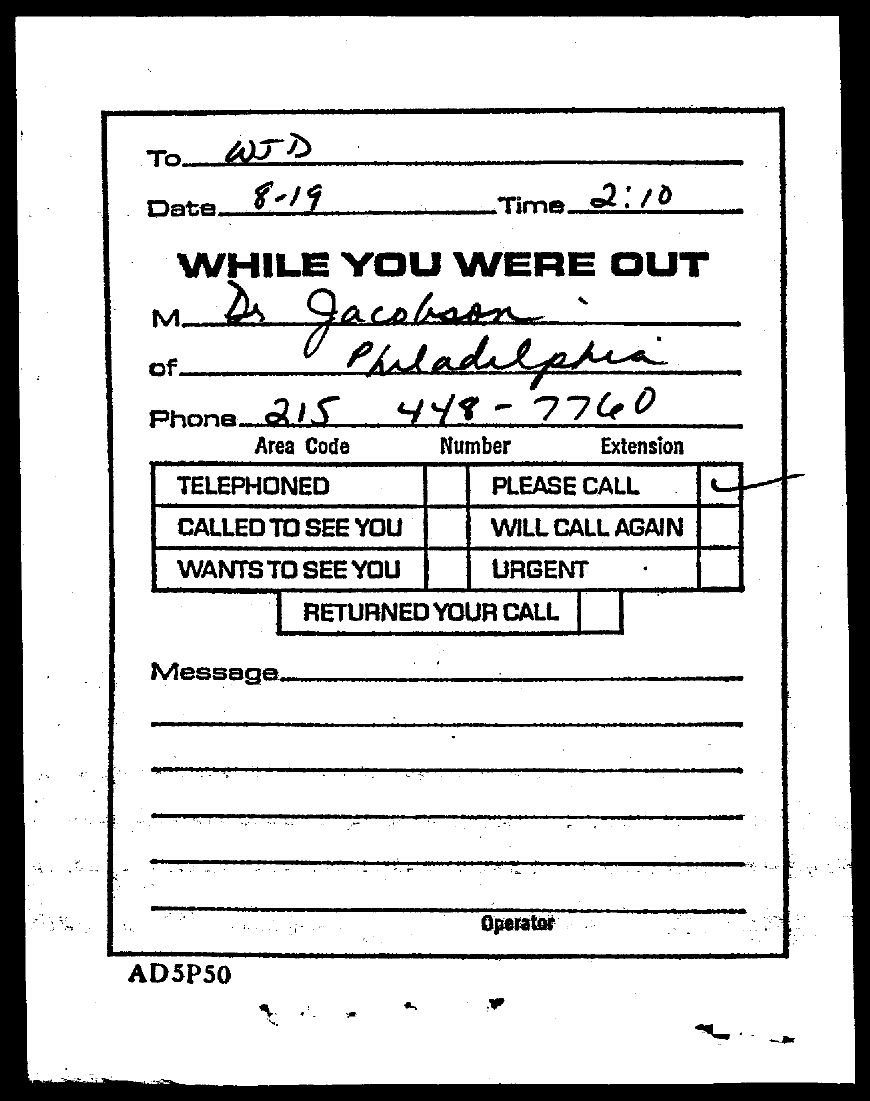What is the phone no of Dr. Jacobson?
Provide a short and direct response. 215 448-7760. To whom, the document is addressed?
Your response must be concise. WJD. What is the date mentioned in this document?
Your answer should be very brief. 8-19. What is the time mentioned in this document?
Provide a short and direct response. 2:10. 